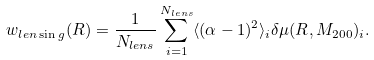Convert formula to latex. <formula><loc_0><loc_0><loc_500><loc_500>w _ { l e n \sin g } ( R ) = \frac { 1 } { N _ { l e n s } } \sum _ { i = 1 } ^ { N _ { l e n s } } \langle ( \alpha - 1 ) ^ { 2 } \rangle _ { i } \delta \mu ( R , M _ { 2 0 0 } ) _ { i } .</formula> 